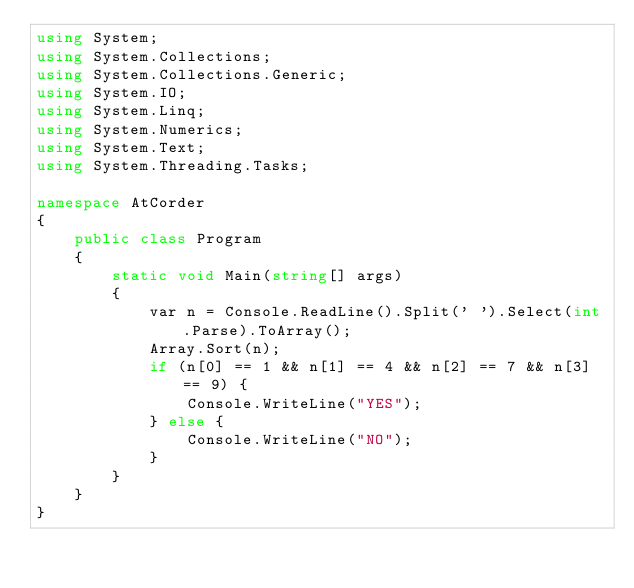<code> <loc_0><loc_0><loc_500><loc_500><_C#_>using System;
using System.Collections;
using System.Collections.Generic;
using System.IO;
using System.Linq;
using System.Numerics;
using System.Text;
using System.Threading.Tasks;

namespace AtCorder
{
	public class Program
	{
		static void Main(string[] args)
		{
			var n = Console.ReadLine().Split(' ').Select(int.Parse).ToArray();
			Array.Sort(n);
			if (n[0] == 1 && n[1] == 4 && n[2] == 7 && n[3] == 9) {
				Console.WriteLine("YES");
			} else {
				Console.WriteLine("NO");
			}
		}
	}
}</code> 